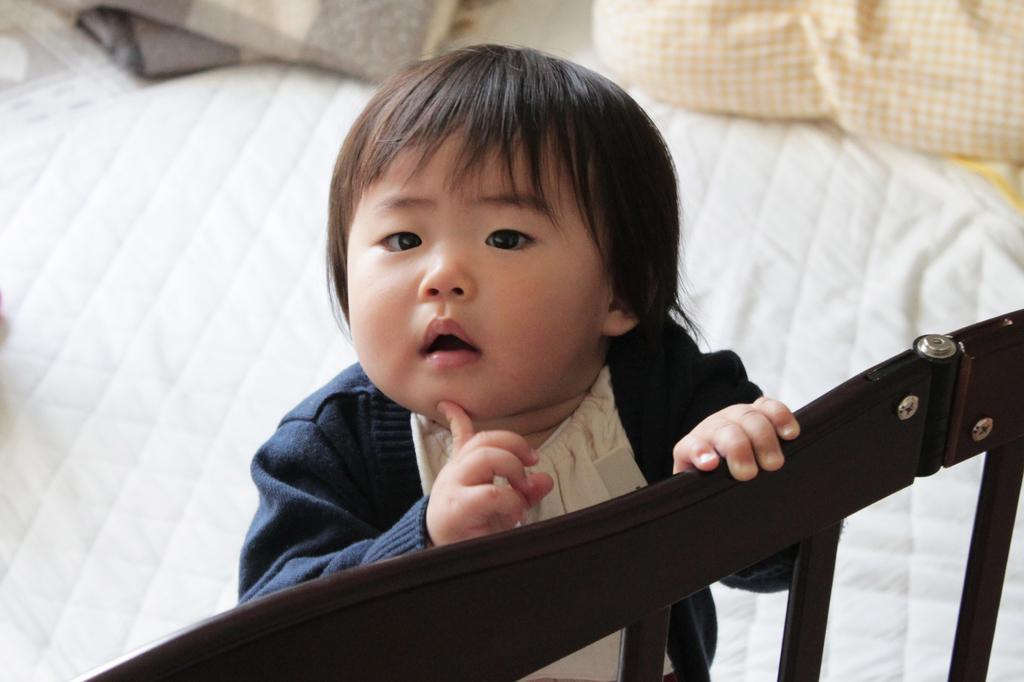Could you give a brief overview of what you see in this image? As we can see in the image, there is a child wearing blue color jacket and standing on bed. 